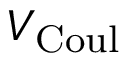<formula> <loc_0><loc_0><loc_500><loc_500>V _ { C o u l }</formula> 